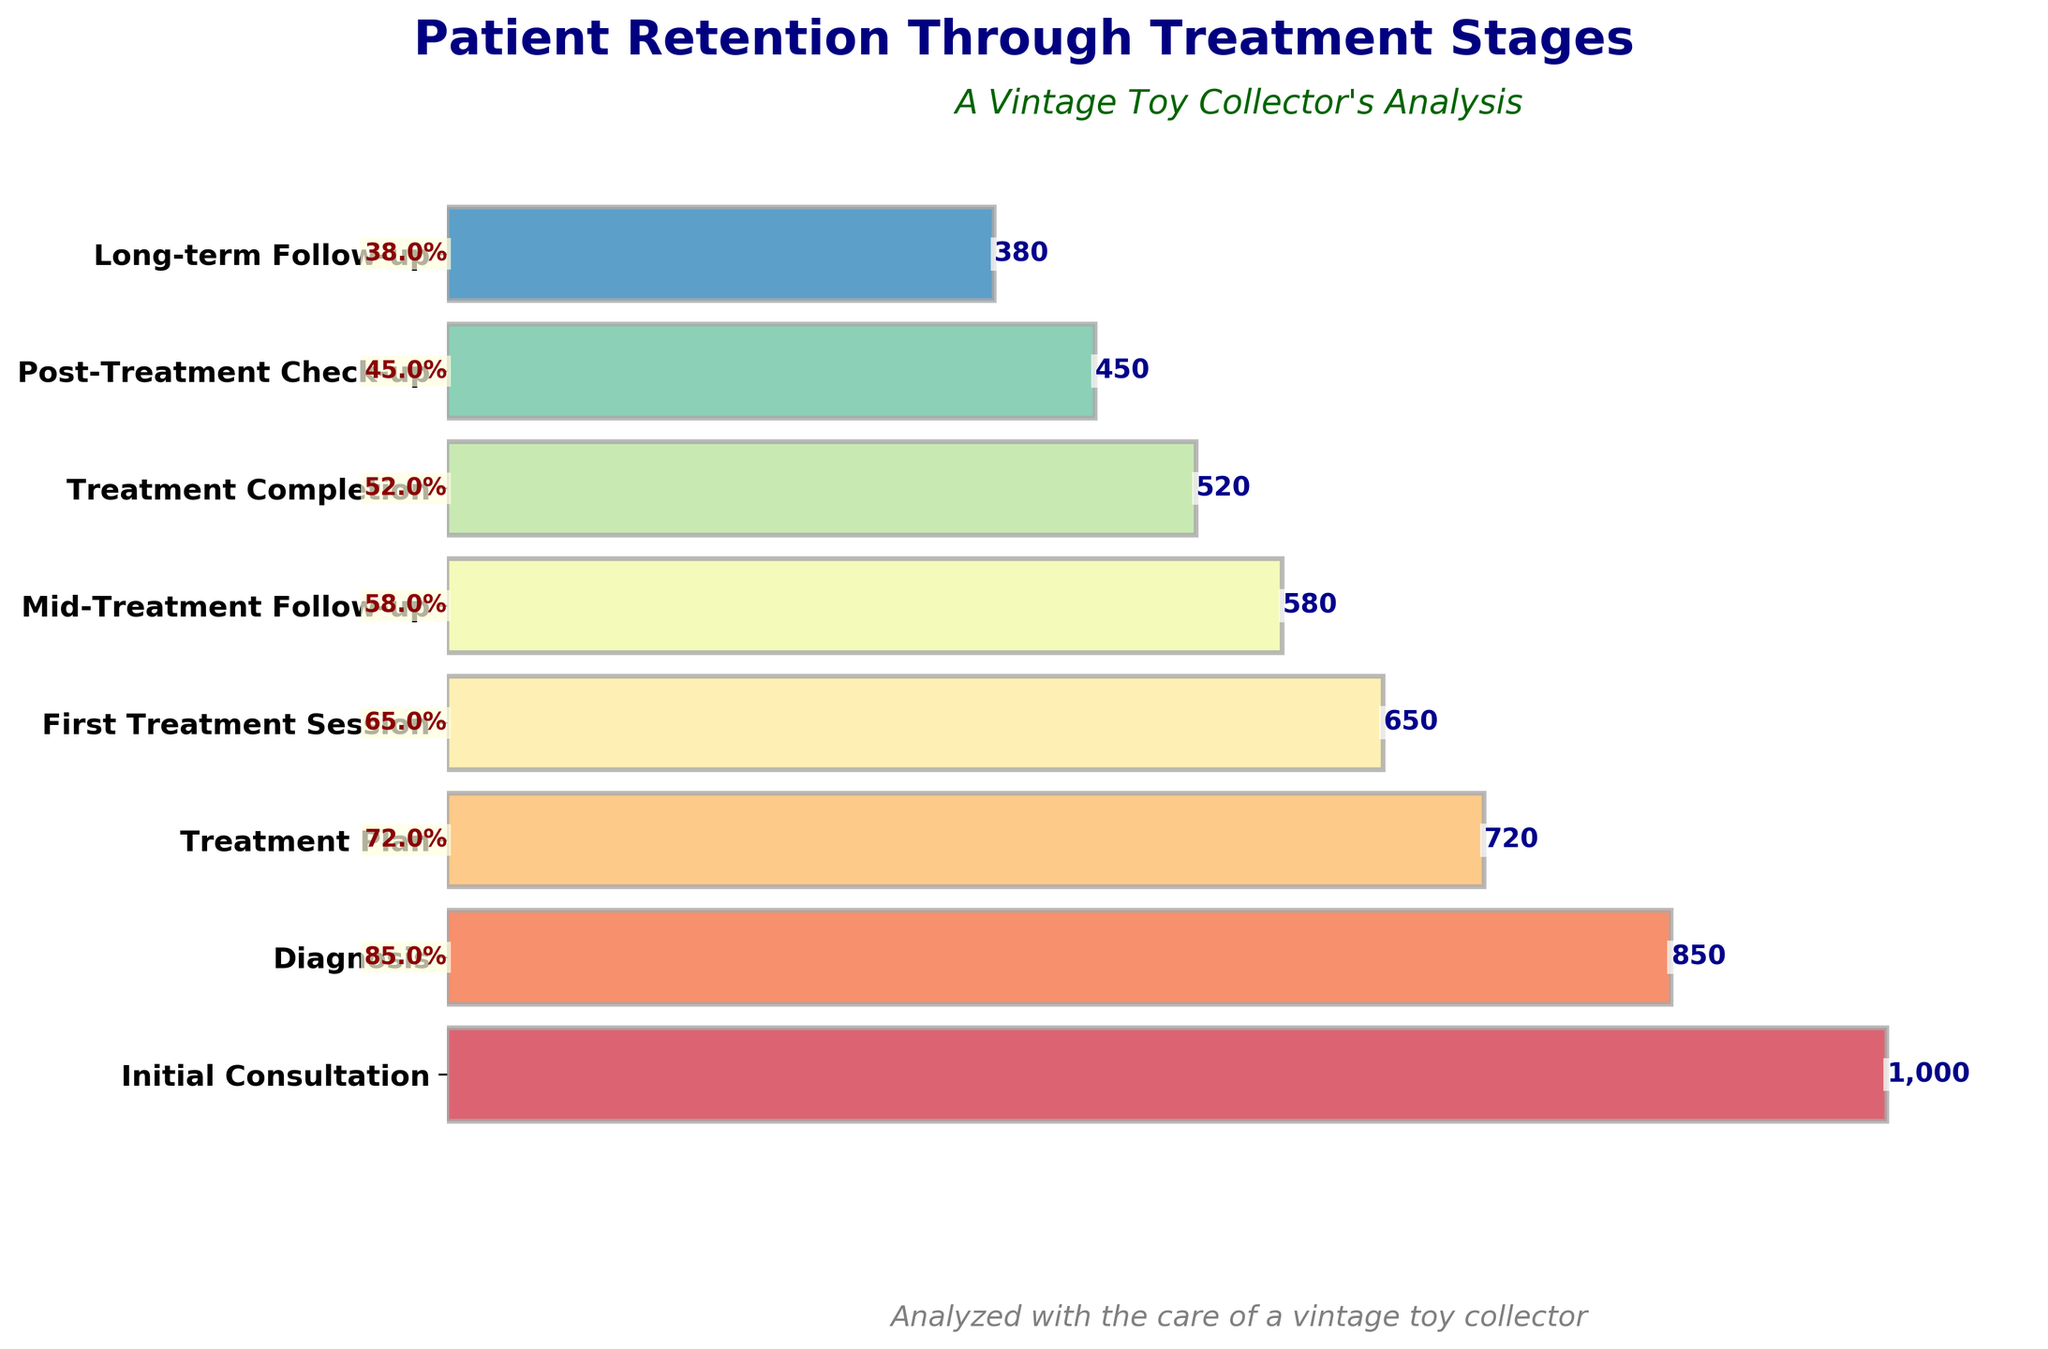What is the title of the funnel chart? The title of the funnel chart is prominently displayed at the top and reads "Patient Retention Through Treatment Stages."
Answer: Patient Retention Through Treatment Stages What stage has the highest number of patients? The stage with the highest number of patients is the first stage in the funnel, which is "Initial Consultation" with 1000 patients.
Answer: Initial Consultation What is the percentage retention from the Initial Consultation to the Diagnosis stage? The number of patients in the Initial Consultation stage is 1000, and in the Diagnosis stage, it is 850. To find the percentage retention, we calculate (850 / 1000) * 100%, which equals 85%.
Answer: 85% How many patients drop out between the Mid-Treatment Follow-up and the Treatment Completion stages? The number of patients in the Mid-Treatment Follow-up stage is 580, and in the Treatment Completion stage, it is 520. The number of patients that drop out is 580 - 520 = 60 patients.
Answer: 60 What is the difference in the number of patients between the First Treatment Session and the Long-term Follow-up stages? The number of patients in the First Treatment Session is 650, and in the Long-term Follow-up, it is 380. The difference is 650 - 380 = 270 patients.
Answer: 270 What is the retention rate from Treatment Completion to Long-term Follow-up? The number of patients in the Treatment Completion stage is 520, and in the Long-term Follow-up stage, it is 380. The retention rate is calculated as (380 / 520) * 100%, which equals approximately 73.1%.
Answer: 73.1% Which stage has the lowest retention rate compared to the Initial Consultation stage? The Long-term Follow-up stage has the lowest retention rate when compared to the Initial Consultation stage. The retention rate is (380 / 1000) * 100%, which is 38%.
Answer: Long-term Follow-up Is the retention between each stage above 50%? Yes. For each transition between stages, the retention rate is calculated and shown next to the bars. All retention rates (e.g., 85% from Initial Consultation to Diagnosis, 72% from Diagnosis to Treatment Plan) are above 50%.
Answer: Yes What does the subtitle under the main title say? The subtitle under the main title reads "A Vintage Toy Collector's Analysis," adding a nostalgic touch to the chart.
Answer: A Vintage Toy Collector's Analysis 